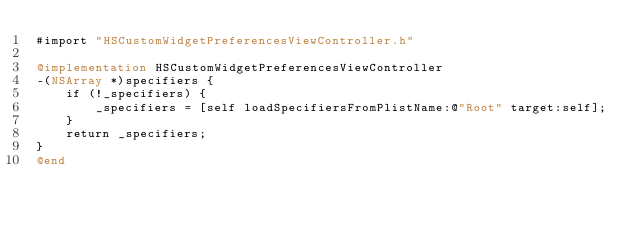<code> <loc_0><loc_0><loc_500><loc_500><_ObjectiveC_>#import "HSCustomWidgetPreferencesViewController.h"

@implementation HSCustomWidgetPreferencesViewController
-(NSArray *)specifiers {
	if (!_specifiers) {
		_specifiers = [self loadSpecifiersFromPlistName:@"Root" target:self];
	}
	return _specifiers;
}
@end
</code> 